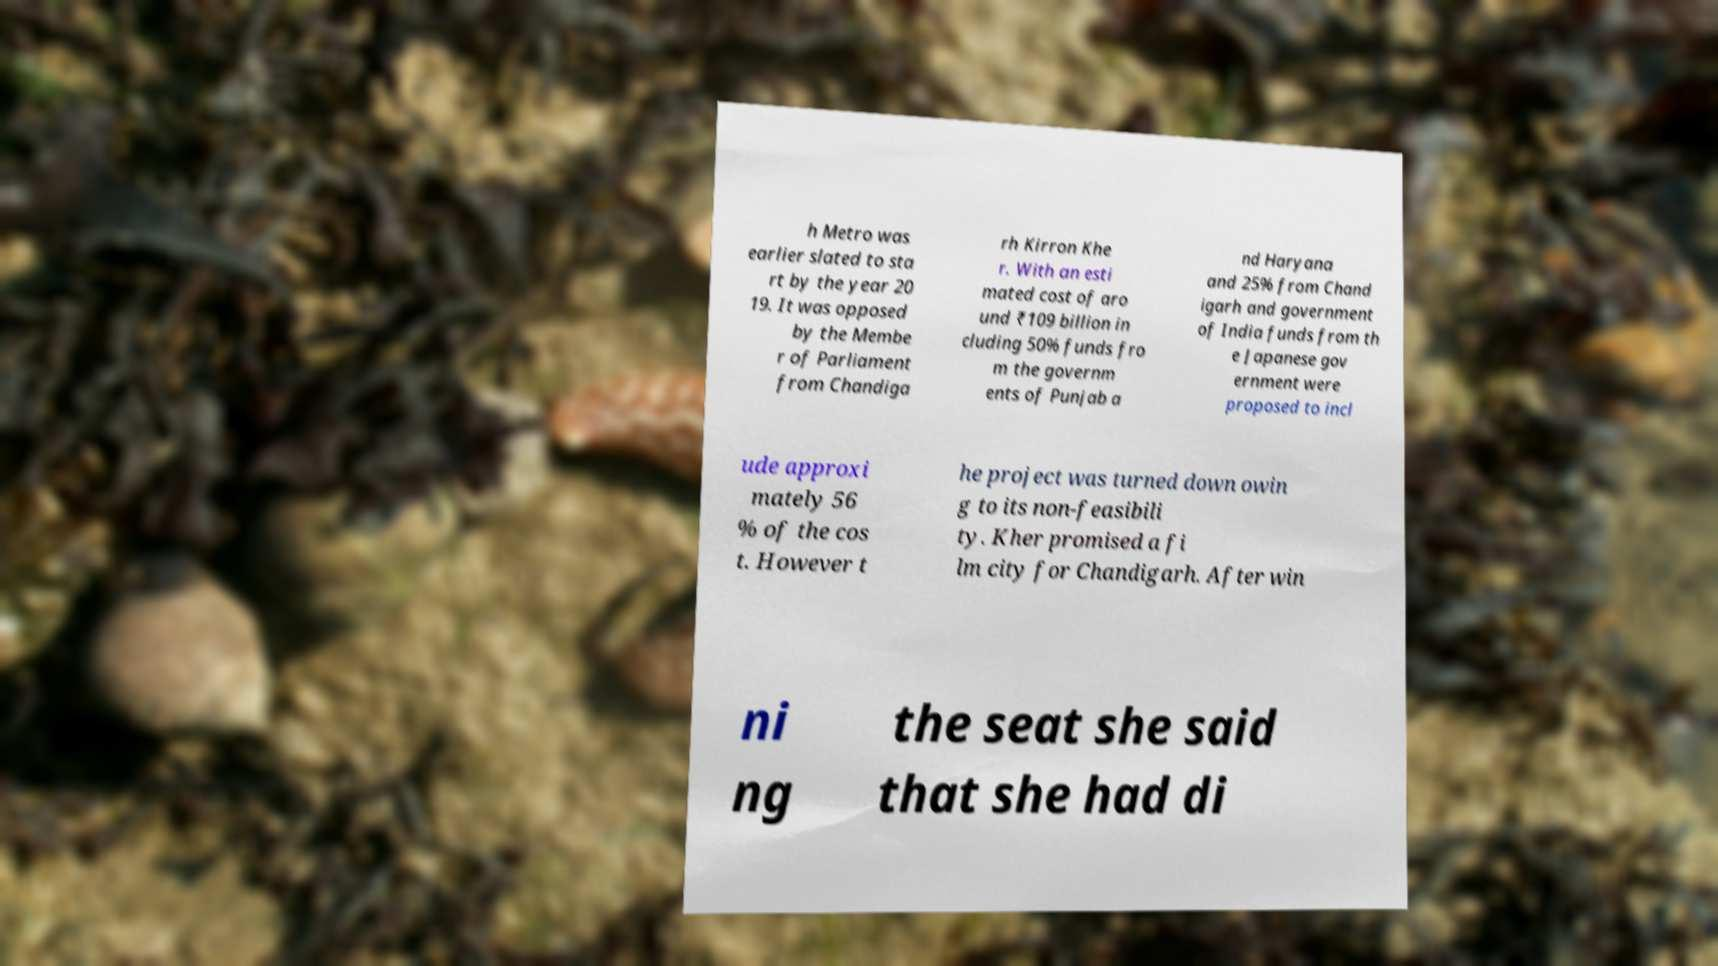Can you read and provide the text displayed in the image?This photo seems to have some interesting text. Can you extract and type it out for me? h Metro was earlier slated to sta rt by the year 20 19. It was opposed by the Membe r of Parliament from Chandiga rh Kirron Khe r. With an esti mated cost of aro und ₹109 billion in cluding 50% funds fro m the governm ents of Punjab a nd Haryana and 25% from Chand igarh and government of India funds from th e Japanese gov ernment were proposed to incl ude approxi mately 56 % of the cos t. However t he project was turned down owin g to its non-feasibili ty. Kher promised a fi lm city for Chandigarh. After win ni ng the seat she said that she had di 